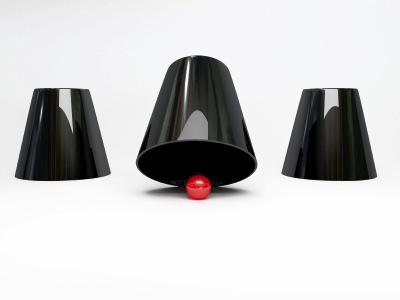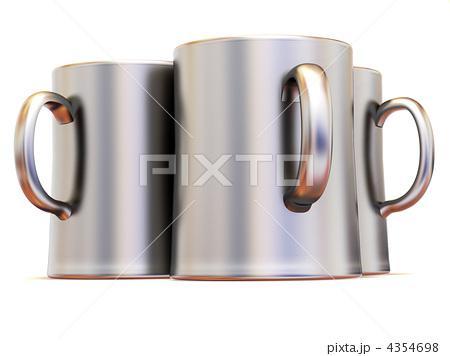The first image is the image on the left, the second image is the image on the right. For the images shown, is this caption "There are three mugs in one of the images." true? Answer yes or no. Yes. The first image is the image on the left, the second image is the image on the right. Evaluate the accuracy of this statement regarding the images: "An image shows a row of three cups that are upside-down.". Is it true? Answer yes or no. Yes. 